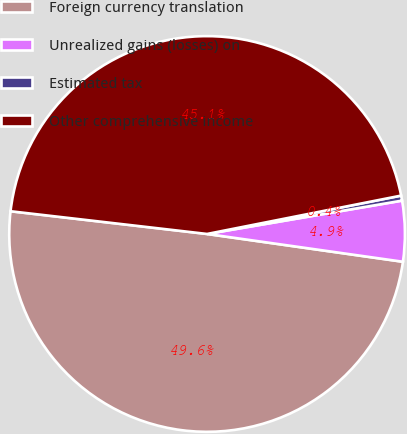Convert chart to OTSL. <chart><loc_0><loc_0><loc_500><loc_500><pie_chart><fcel>Foreign currency translation<fcel>Unrealized gains (losses) on<fcel>Estimated tax<fcel>Other comprehensive income<nl><fcel>49.59%<fcel>4.94%<fcel>0.41%<fcel>45.06%<nl></chart> 